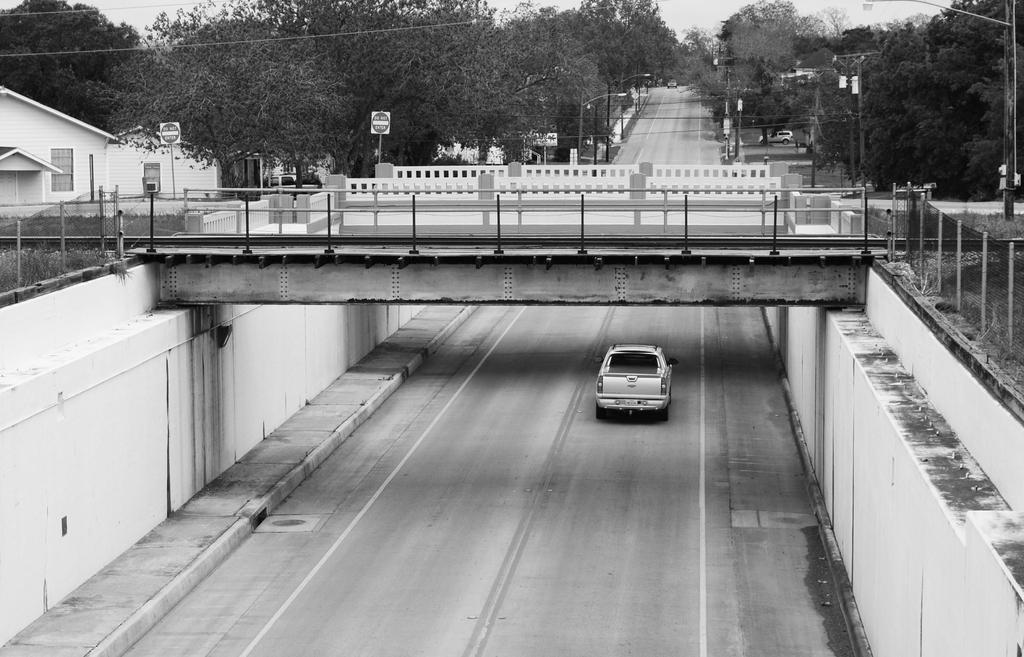Can you describe this image briefly? It is a black and white image, there is a road and on the road there is a vehicle. There is a bridge across the road and on the left side there is house and there are plenty of trees around the road. 